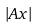Convert formula to latex. <formula><loc_0><loc_0><loc_500><loc_500>| A x |</formula> 